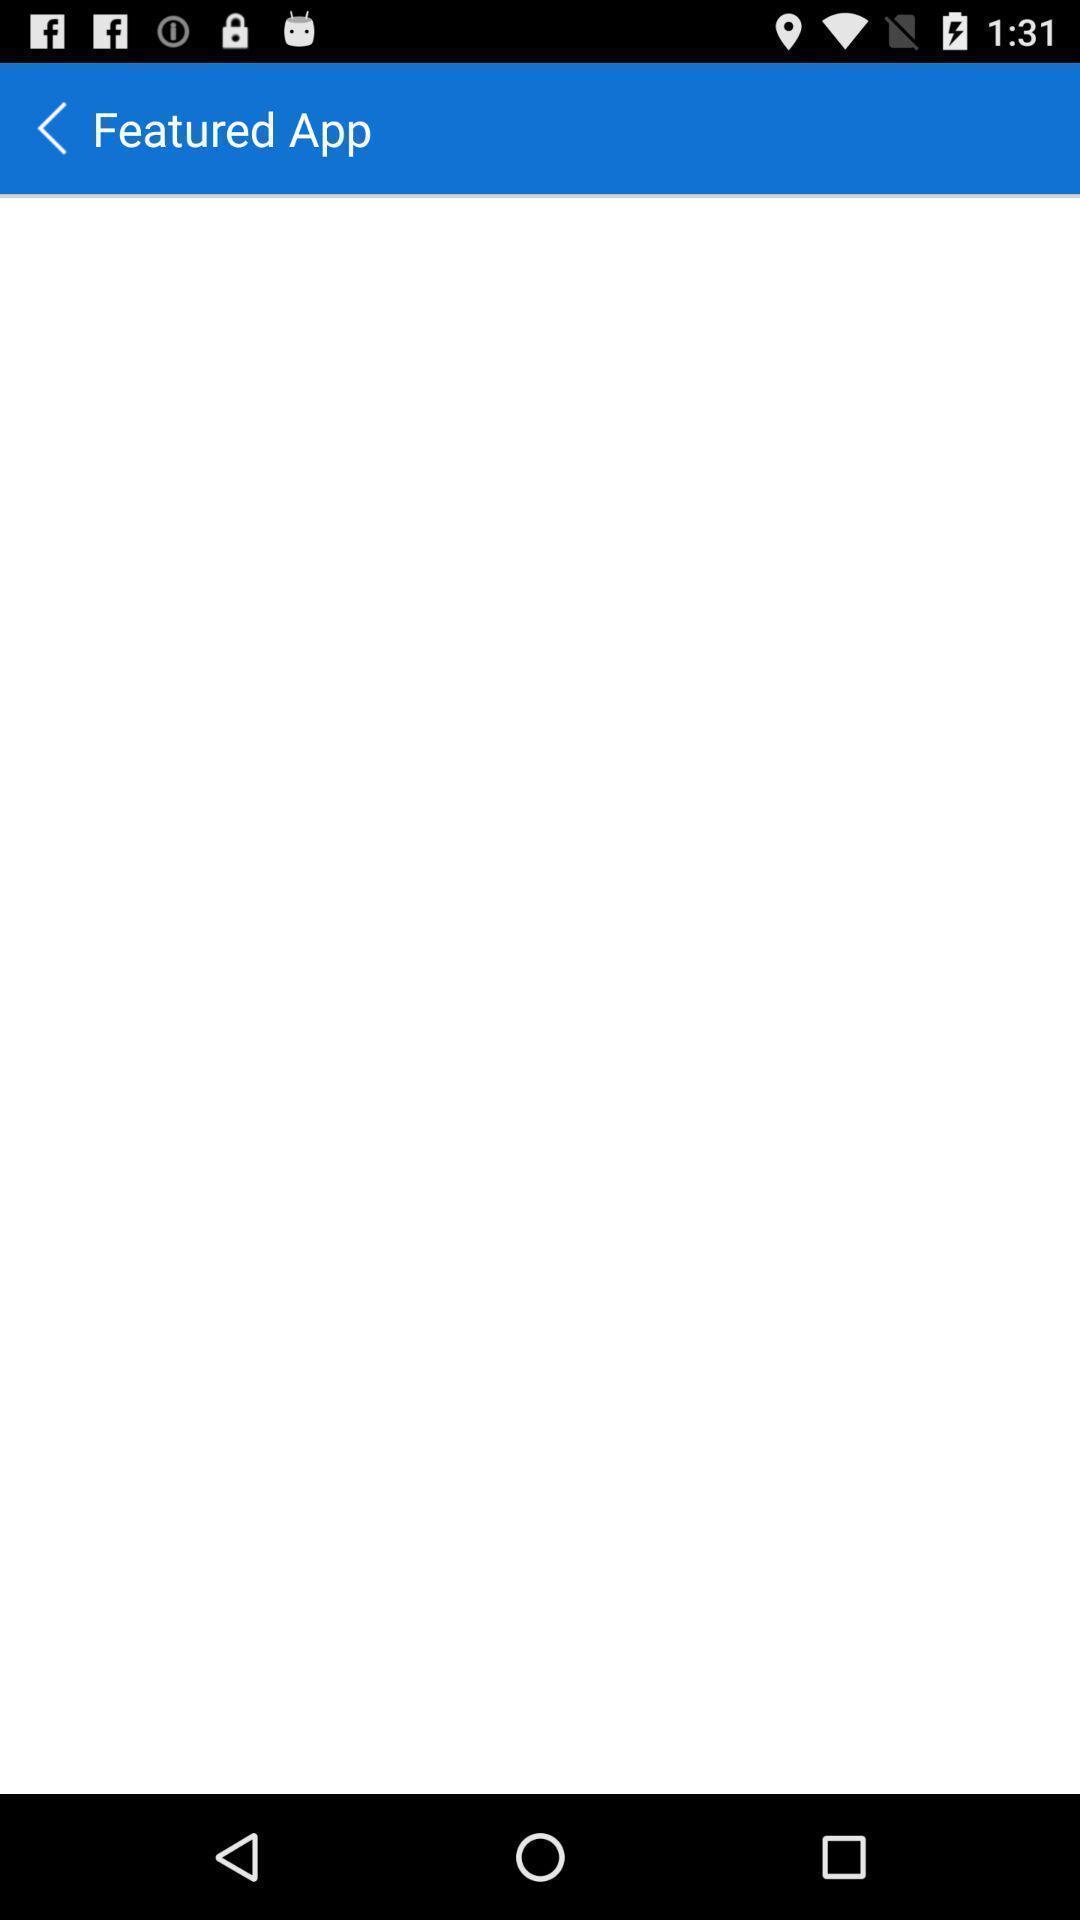Provide a description of this screenshot. Page showing featured app with blank options under it. 